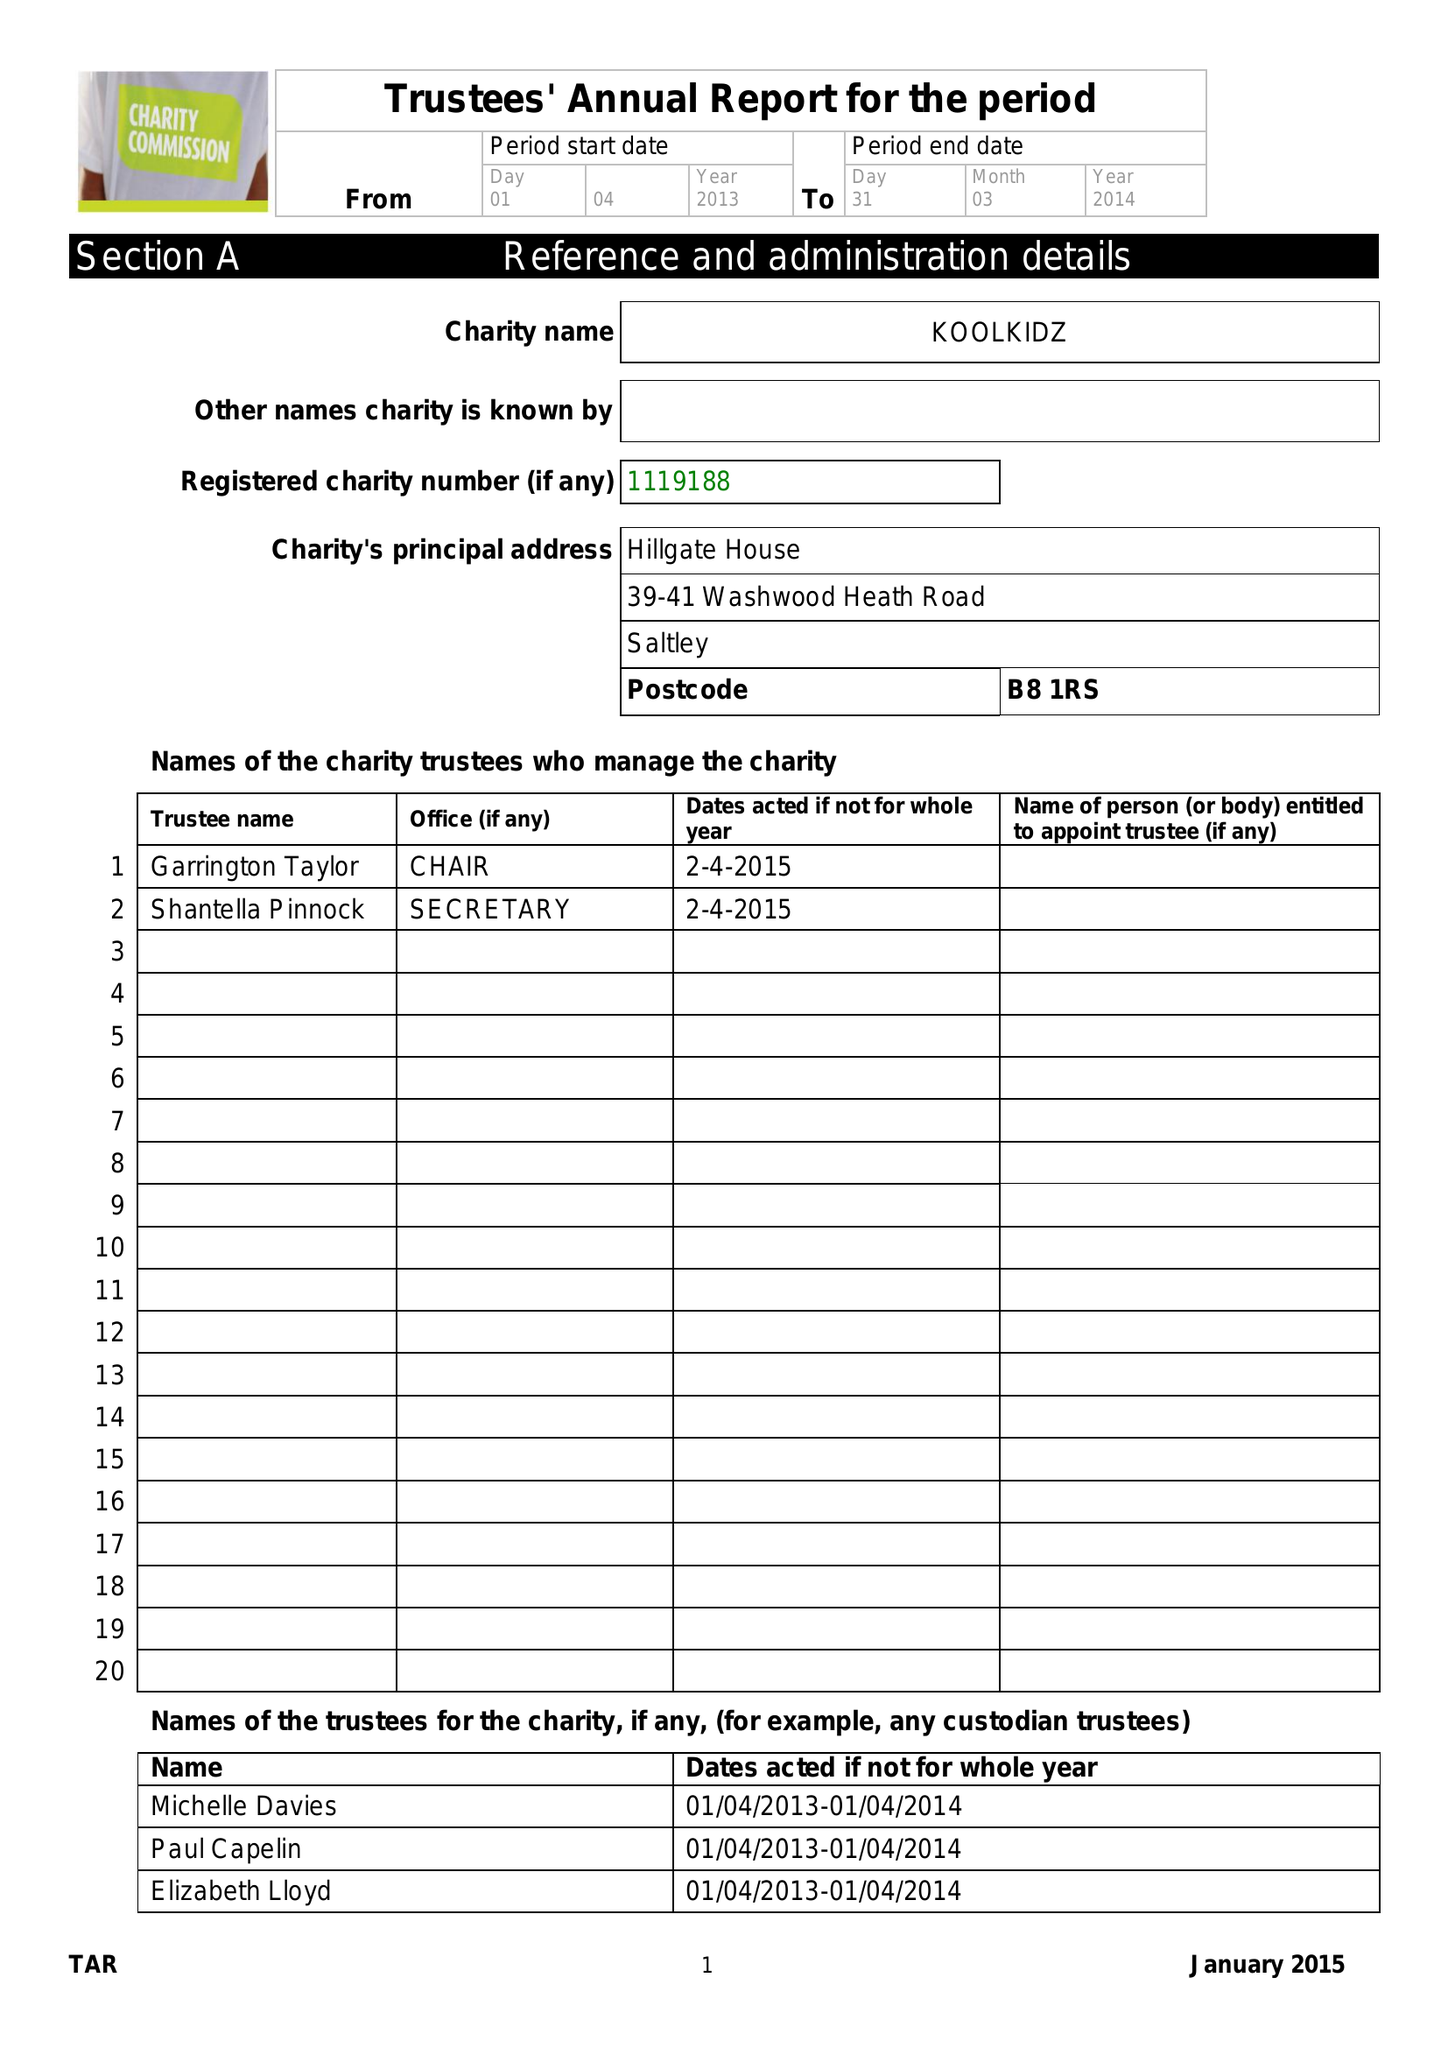What is the value for the report_date?
Answer the question using a single word or phrase. 2014-03-31 